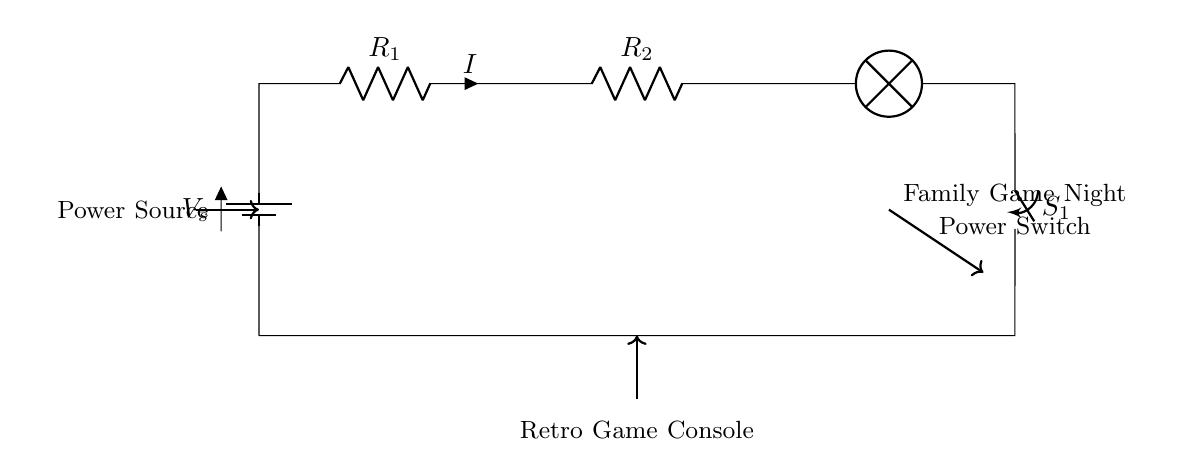What is the type of circuit depicted? The circuit is a series circuit as all components are connected end-to-end, creating a single path for current flow.
Answer: Series circuit What last component does the current flow through? The last component in the diagram is the lamp, which represents the output load of the circuit and where the current ultimately flows.
Answer: Lamp How many resistors are present in the circuit? There are two resistors shown in the circuit diagram, identified as R1 and R2.
Answer: Two What is the role of the switch in this circuit? The switch controls the flow of current; when opened, it creates a break in the circuit, stopping current from reaching the retro game console.
Answer: Control What happens to the current if one resistor fails? In a series circuit, if one resistor fails (opens), it interrupts the entire current flow, causing all components to stop working since there is only one path.
Answer: Stops What is powering the circuit? The circuit is powered by a battery labeled as V_s, which provides the necessary voltage to drive the current through the components.
Answer: Battery What type of load is represented in this circuit? The load in this circuit is a lamp, which typically indicates that it should illuminate when current flows through it.
Answer: Lamp 